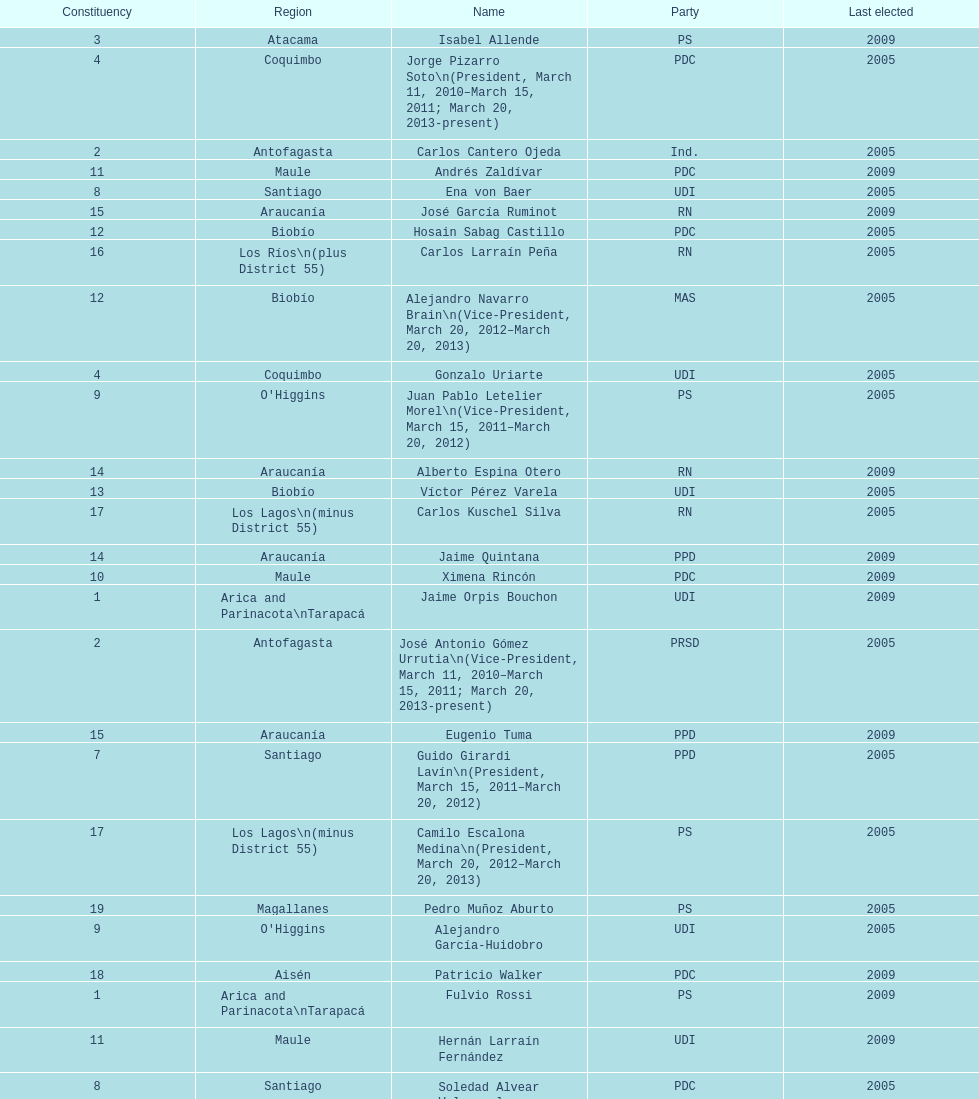Can you give me this table as a dict? {'header': ['Constituency', 'Region', 'Name', 'Party', 'Last elected'], 'rows': [['3', 'Atacama', 'Isabel Allende', 'PS', '2009'], ['4', 'Coquimbo', 'Jorge Pizarro Soto\\n(President, March 11, 2010–March 15, 2011; March 20, 2013-present)', 'PDC', '2005'], ['2', 'Antofagasta', 'Carlos Cantero Ojeda', 'Ind.', '2005'], ['11', 'Maule', 'Andrés Zaldívar', 'PDC', '2009'], ['8', 'Santiago', 'Ena von Baer', 'UDI', '2005'], ['15', 'Araucanía', 'José García Ruminot', 'RN', '2009'], ['12', 'Biobío', 'Hosain Sabag Castillo', 'PDC', '2005'], ['16', 'Los Ríos\\n(plus District 55)', 'Carlos Larraín Peña', 'RN', '2005'], ['12', 'Biobío', 'Alejandro Navarro Brain\\n(Vice-President, March 20, 2012–March 20, 2013)', 'MAS', '2005'], ['4', 'Coquimbo', 'Gonzalo Uriarte', 'UDI', '2005'], ['9', "O'Higgins", 'Juan Pablo Letelier Morel\\n(Vice-President, March 15, 2011–March 20, 2012)', 'PS', '2005'], ['14', 'Araucanía', 'Alberto Espina Otero', 'RN', '2009'], ['13', 'Biobío', 'Víctor Pérez Varela', 'UDI', '2005'], ['17', 'Los Lagos\\n(minus District 55)', 'Carlos Kuschel Silva', 'RN', '2005'], ['14', 'Araucanía', 'Jaime Quintana', 'PPD', '2009'], ['10', 'Maule', 'Ximena Rincón', 'PDC', '2009'], ['1', 'Arica and Parinacota\\nTarapacá', 'Jaime Orpis Bouchon', 'UDI', '2009'], ['2', 'Antofagasta', 'José Antonio Gómez Urrutia\\n(Vice-President, March 11, 2010–March 15, 2011; March 20, 2013-present)', 'PRSD', '2005'], ['15', 'Araucanía', 'Eugenio Tuma', 'PPD', '2009'], ['7', 'Santiago', 'Guido Girardi Lavín\\n(President, March 15, 2011–March 20, 2012)', 'PPD', '2005'], ['17', 'Los Lagos\\n(minus District 55)', 'Camilo Escalona Medina\\n(President, March 20, 2012–March 20, 2013)', 'PS', '2005'], ['19', 'Magallanes', 'Pedro Muñoz Aburto', 'PS', '2005'], ['9', "O'Higgins", 'Alejandro García-Huidobro', 'UDI', '2005'], ['18', 'Aisén', 'Patricio Walker', 'PDC', '2009'], ['1', 'Arica and Parinacota\\nTarapacá', 'Fulvio Rossi', 'PS', '2009'], ['11', 'Maule', 'Hernán Larraín Fernández', 'UDI', '2009'], ['8', 'Santiago', 'Soledad Alvear Valenzuela', 'PDC', '2005'], ['5', 'Valparaíso', 'Lily Pérez', 'RN', '2009'], ['19', 'Magallanes', 'Carlos Bianchi Chelech\\n(Vice-President, March 13, 2009–March 11, 2010)', 'Ind.', '2005'], ['16', 'Los Ríos\\n(plus District 55)', 'Eduardo Frei Ruiz-Tagle\\n(President, March 11, 2006-March 12, 2008)', 'PDC', '2005'], ['5', 'Valparaíso', 'Ignacio Walker', 'PDC', '2009'], ['7', 'Santiago', 'Jovino Novoa Vásquez\\n(President, March 13, 2009–March 11, 2010)', 'UDI', '2005'], ['10', 'Maule', 'Juan Antonio Coloma Correa', 'UDI', '2009'], ['6', 'Valparaíso', 'Francisco Chahuan', 'RN', '2009'], ['6', 'Valparaíso', 'Ricardo L. Weber', 'PPD', '2009'], ['13', 'Biobío', 'Mariano Ruiz-Esquide Jara', 'PDC', '2005'], ['18', 'Aisén', 'Antonio Horvath Kiss', 'RN', '2001'], ['3', 'Atacama', 'Baldo Prokurica Prokurica\\n(Vice-President, March 12, 2008-March 13, 2009)', 'RN', '2009']]} In the table, which region is listed at the end? Magallanes. 